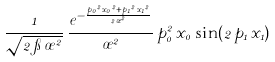<formula> <loc_0><loc_0><loc_500><loc_500>\frac { 1 } { { \sqrt { 2 \, \pi \, { \sigma } ^ { 2 } } } } \, \frac { e ^ { - \frac { { p _ { 0 } } ^ { 2 } \, { x _ { 0 } } ^ { 2 } + { p _ { 1 } } ^ { 2 } \, { x _ { 1 } } ^ { 2 } } { 2 \, { \sigma } ^ { 2 } } } } { { \sigma } ^ { 2 } } \, { p _ { 0 } ^ { 2 } } \, { x _ { 0 } } \, \sin ( 2 \, { p _ { 1 } } \, { x _ { 1 } } )</formula> 